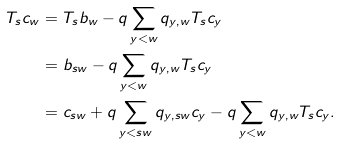Convert formula to latex. <formula><loc_0><loc_0><loc_500><loc_500>T _ { s } c _ { w } & = T _ { s } b _ { w } - q \sum _ { y < w } q _ { y , w } T _ { s } c _ { y } \\ & = b _ { s w } - q \sum _ { y < w } q _ { y , w } T _ { s } c _ { y } \\ & = c _ { s w } + q \sum _ { y < s w } q _ { y , s w } c _ { y } - q \sum _ { y < w } q _ { y , w } T _ { s } c _ { y } .</formula> 